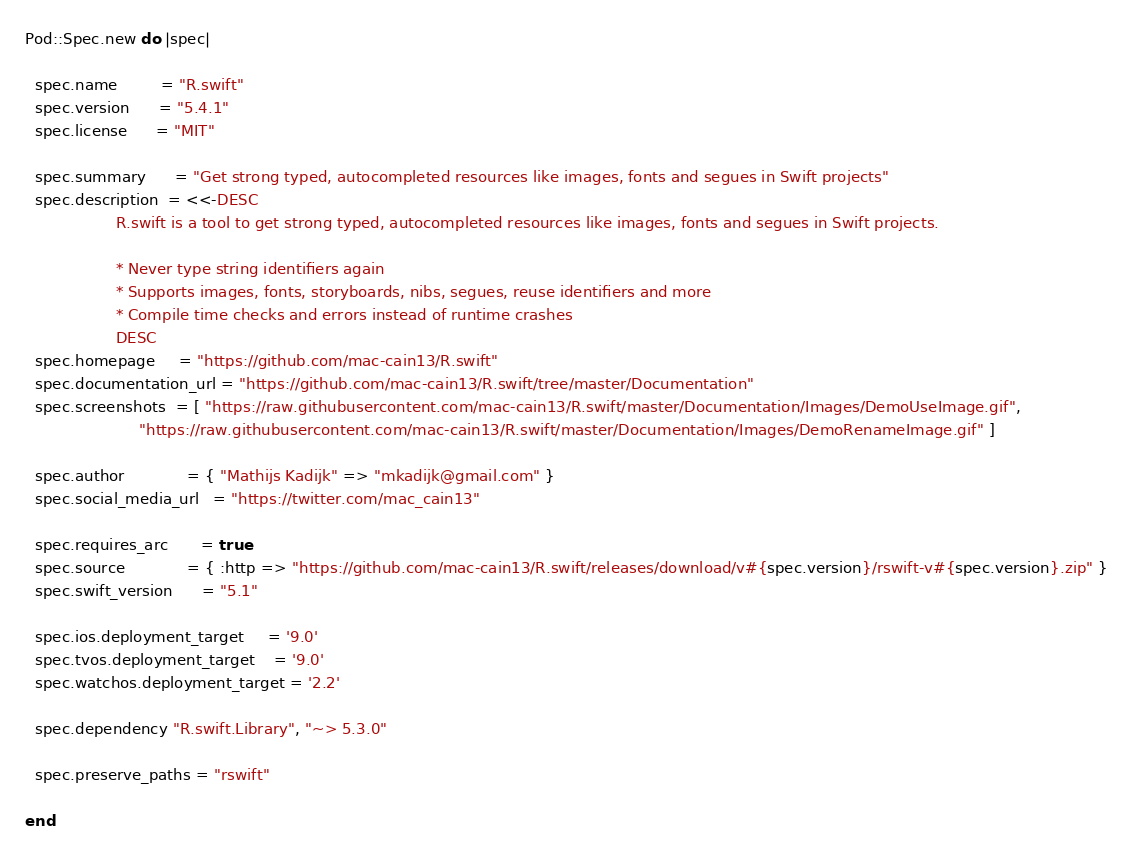Convert code to text. <code><loc_0><loc_0><loc_500><loc_500><_Ruby_>Pod::Spec.new do |spec|

  spec.name         = "R.swift"
  spec.version      = "5.4.1"
  spec.license      = "MIT"

  spec.summary      = "Get strong typed, autocompleted resources like images, fonts and segues in Swift projects"
  spec.description  = <<-DESC
                   R.swift is a tool to get strong typed, autocompleted resources like images, fonts and segues in Swift projects.

                   * Never type string identifiers again
                   * Supports images, fonts, storyboards, nibs, segues, reuse identifiers and more
                   * Compile time checks and errors instead of runtime crashes
                   DESC
  spec.homepage     = "https://github.com/mac-cain13/R.swift"
  spec.documentation_url = "https://github.com/mac-cain13/R.swift/tree/master/Documentation"
  spec.screenshots  = [ "https://raw.githubusercontent.com/mac-cain13/R.swift/master/Documentation/Images/DemoUseImage.gif",
                        "https://raw.githubusercontent.com/mac-cain13/R.swift/master/Documentation/Images/DemoRenameImage.gif" ]

  spec.author             = { "Mathijs Kadijk" => "mkadijk@gmail.com" }
  spec.social_media_url   = "https://twitter.com/mac_cain13"

  spec.requires_arc       = true
  spec.source             = { :http => "https://github.com/mac-cain13/R.swift/releases/download/v#{spec.version}/rswift-v#{spec.version}.zip" }
  spec.swift_version      = "5.1"

  spec.ios.deployment_target     = '9.0'
  spec.tvos.deployment_target    = '9.0'
  spec.watchos.deployment_target = '2.2'

  spec.dependency "R.swift.Library", "~> 5.3.0"

  spec.preserve_paths = "rswift"

end
</code> 